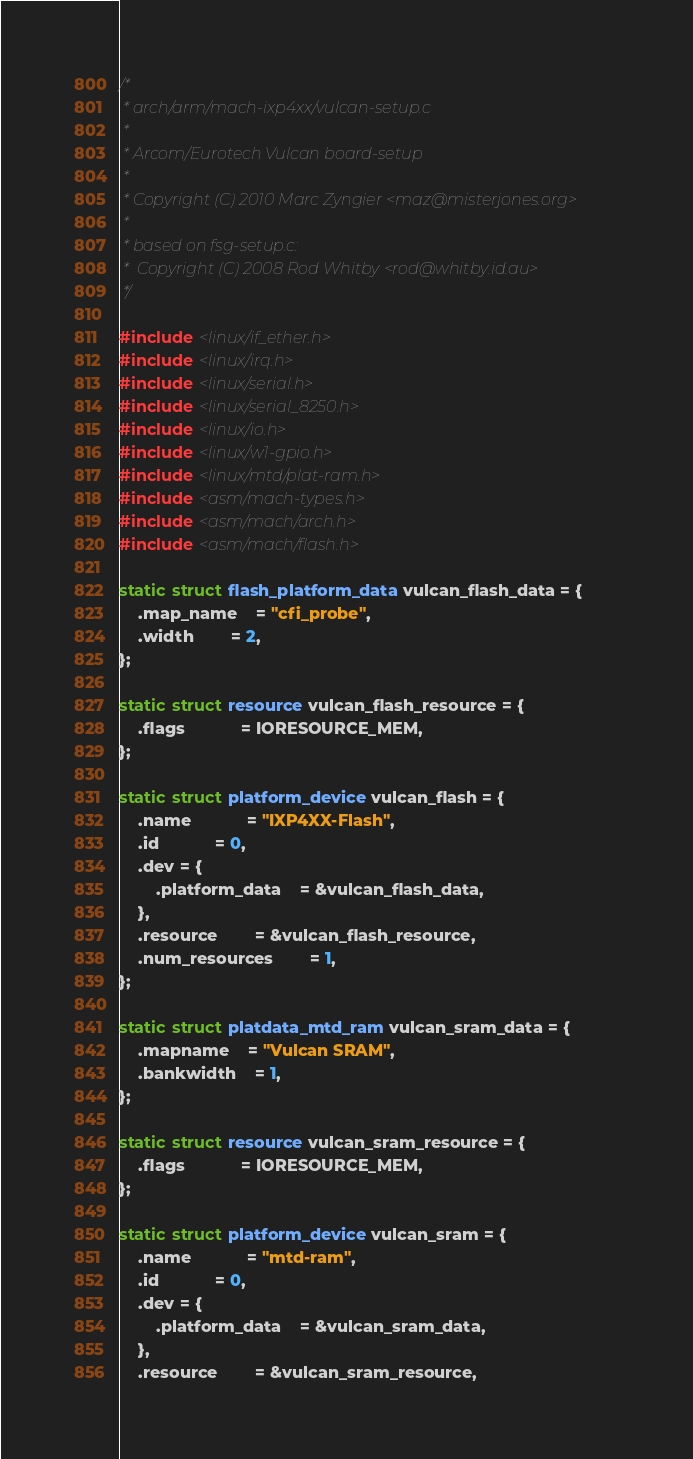<code> <loc_0><loc_0><loc_500><loc_500><_C_>/*
 * arch/arm/mach-ixp4xx/vulcan-setup.c
 *
 * Arcom/Eurotech Vulcan board-setup
 *
 * Copyright (C) 2010 Marc Zyngier <maz@misterjones.org>
 *
 * based on fsg-setup.c:
 *	Copyright (C) 2008 Rod Whitby <rod@whitby.id.au>
 */

#include <linux/if_ether.h>
#include <linux/irq.h>
#include <linux/serial.h>
#include <linux/serial_8250.h>
#include <linux/io.h>
#include <linux/w1-gpio.h>
#include <linux/mtd/plat-ram.h>
#include <asm/mach-types.h>
#include <asm/mach/arch.h>
#include <asm/mach/flash.h>

static struct flash_platform_data vulcan_flash_data = {
	.map_name	= "cfi_probe",
	.width		= 2,
};

static struct resource vulcan_flash_resource = {
	.flags			= IORESOURCE_MEM,
};

static struct platform_device vulcan_flash = {
	.name			= "IXP4XX-Flash",
	.id			= 0,
	.dev = {
		.platform_data	= &vulcan_flash_data,
	},
	.resource		= &vulcan_flash_resource,
	.num_resources		= 1,
};

static struct platdata_mtd_ram vulcan_sram_data = {
	.mapname	= "Vulcan SRAM",
	.bankwidth	= 1,
};

static struct resource vulcan_sram_resource = {
	.flags			= IORESOURCE_MEM,
};

static struct platform_device vulcan_sram = {
	.name			= "mtd-ram",
	.id			= 0,
	.dev = {
		.platform_data	= &vulcan_sram_data,
	},
	.resource		= &vulcan_sram_resource,</code> 